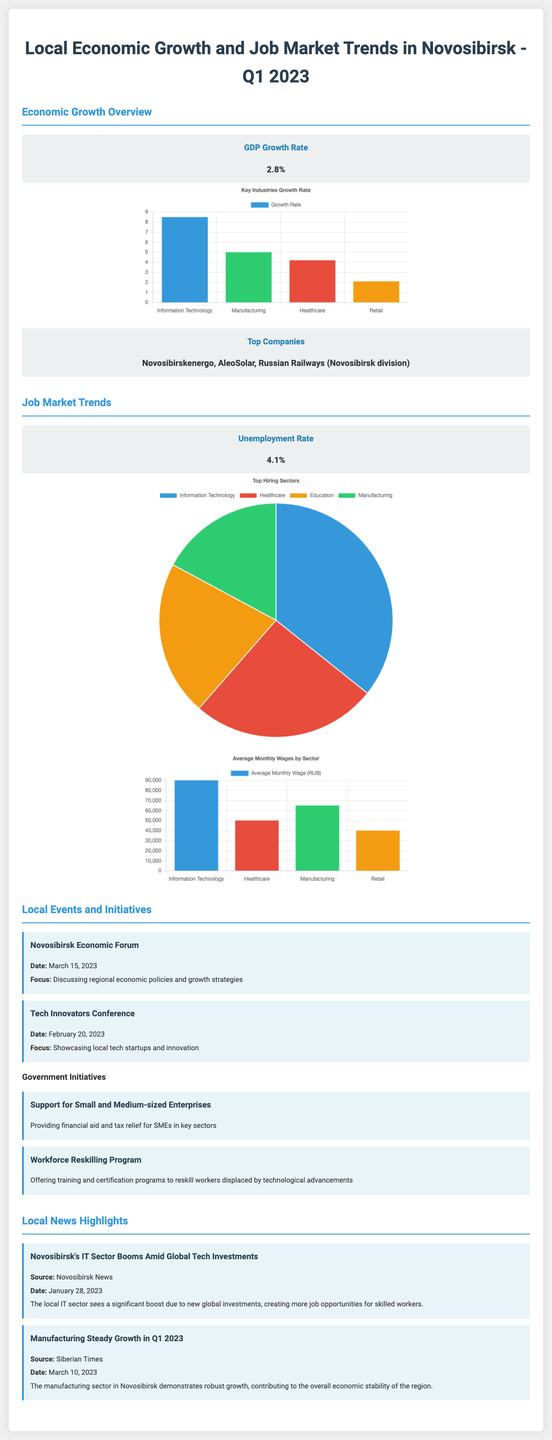What is the GDP growth rate for Novosibirsk in Q1 2023? The GDP growth rate is stated in the Economic Growth Overview section of the document.
Answer: 2.8% What is the unemployment rate in Novosibirsk? The unemployment rate is provided in the Job Market Trends section of the document.
Answer: 4.1% Which company is listed as a top company in Novosibirsk? The top companies are mentioned in the Economic Growth Overview section, highlighting significant local entities.
Answer: Novosibirskenergo Which sector has the highest growth rate according to the chart? This requires comparing the growth rates of different sectors shown in the Key Industries Growth Rate chart.
Answer: Information Technology What percentage of hiring is represented by the healthcare sector? The question refers to the pie chart titled Top Hiring Sectors, where the healthcare sector's share is indicated.
Answer: 18% What event took place on March 15, 2023? The title and date of the event are detailed in the Local Events and Initiatives section.
Answer: Novosibirsk Economic Forum What is the average monthly wage in the information technology sector? The data for average monthly wages is depicted in the Average Monthly Wages chart.
Answer: 90000 What is the focus of the Workforce Reskilling Program? The focus is summarized in the list of government initiatives concerning workforce development.
Answer: Offering training and certification programs Which news source reported on Novosibirsk's IT sector boom? The news highlights provide sources for the coverage of local events and industry news.
Answer: Novosibirsk News 